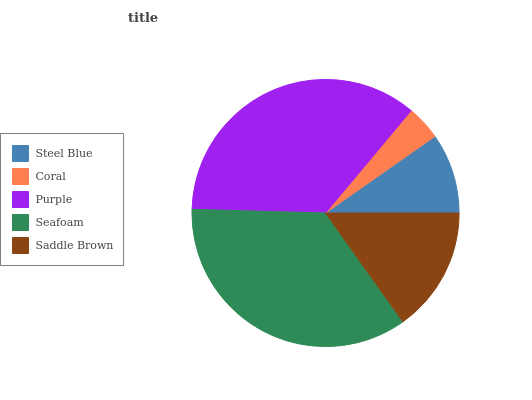Is Coral the minimum?
Answer yes or no. Yes. Is Purple the maximum?
Answer yes or no. Yes. Is Purple the minimum?
Answer yes or no. No. Is Coral the maximum?
Answer yes or no. No. Is Purple greater than Coral?
Answer yes or no. Yes. Is Coral less than Purple?
Answer yes or no. Yes. Is Coral greater than Purple?
Answer yes or no. No. Is Purple less than Coral?
Answer yes or no. No. Is Saddle Brown the high median?
Answer yes or no. Yes. Is Saddle Brown the low median?
Answer yes or no. Yes. Is Steel Blue the high median?
Answer yes or no. No. Is Seafoam the low median?
Answer yes or no. No. 